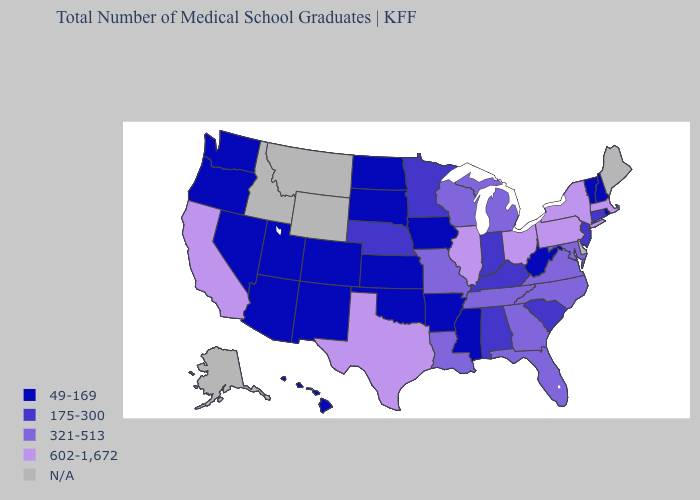Name the states that have a value in the range 602-1,672?
Keep it brief. California, Illinois, Massachusetts, New York, Ohio, Pennsylvania, Texas. Does North Dakota have the lowest value in the MidWest?
Quick response, please. Yes. Is the legend a continuous bar?
Keep it brief. No. Name the states that have a value in the range N/A?
Short answer required. Alaska, Delaware, Idaho, Maine, Montana, Wyoming. Does Missouri have the lowest value in the USA?
Concise answer only. No. Name the states that have a value in the range 49-169?
Write a very short answer. Arizona, Arkansas, Colorado, Hawaii, Iowa, Kansas, Mississippi, Nevada, New Hampshire, New Mexico, North Dakota, Oklahoma, Oregon, Rhode Island, South Dakota, Utah, Vermont, Washington, West Virginia. Does California have the lowest value in the West?
Concise answer only. No. Name the states that have a value in the range 321-513?
Keep it brief. Florida, Georgia, Louisiana, Maryland, Michigan, Missouri, North Carolina, Tennessee, Virginia, Wisconsin. Does the map have missing data?
Short answer required. Yes. What is the value of Montana?
Keep it brief. N/A. What is the value of New Mexico?
Quick response, please. 49-169. Name the states that have a value in the range 321-513?
Concise answer only. Florida, Georgia, Louisiana, Maryland, Michigan, Missouri, North Carolina, Tennessee, Virginia, Wisconsin. Which states have the lowest value in the USA?
Be succinct. Arizona, Arkansas, Colorado, Hawaii, Iowa, Kansas, Mississippi, Nevada, New Hampshire, New Mexico, North Dakota, Oklahoma, Oregon, Rhode Island, South Dakota, Utah, Vermont, Washington, West Virginia. What is the highest value in states that border Maryland?
Answer briefly. 602-1,672. 